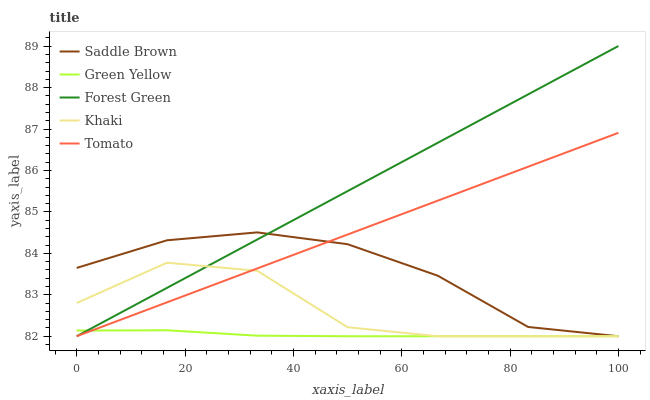Does Forest Green have the minimum area under the curve?
Answer yes or no. No. Does Green Yellow have the maximum area under the curve?
Answer yes or no. No. Is Green Yellow the smoothest?
Answer yes or no. No. Is Green Yellow the roughest?
Answer yes or no. No. Does Green Yellow have the highest value?
Answer yes or no. No. 